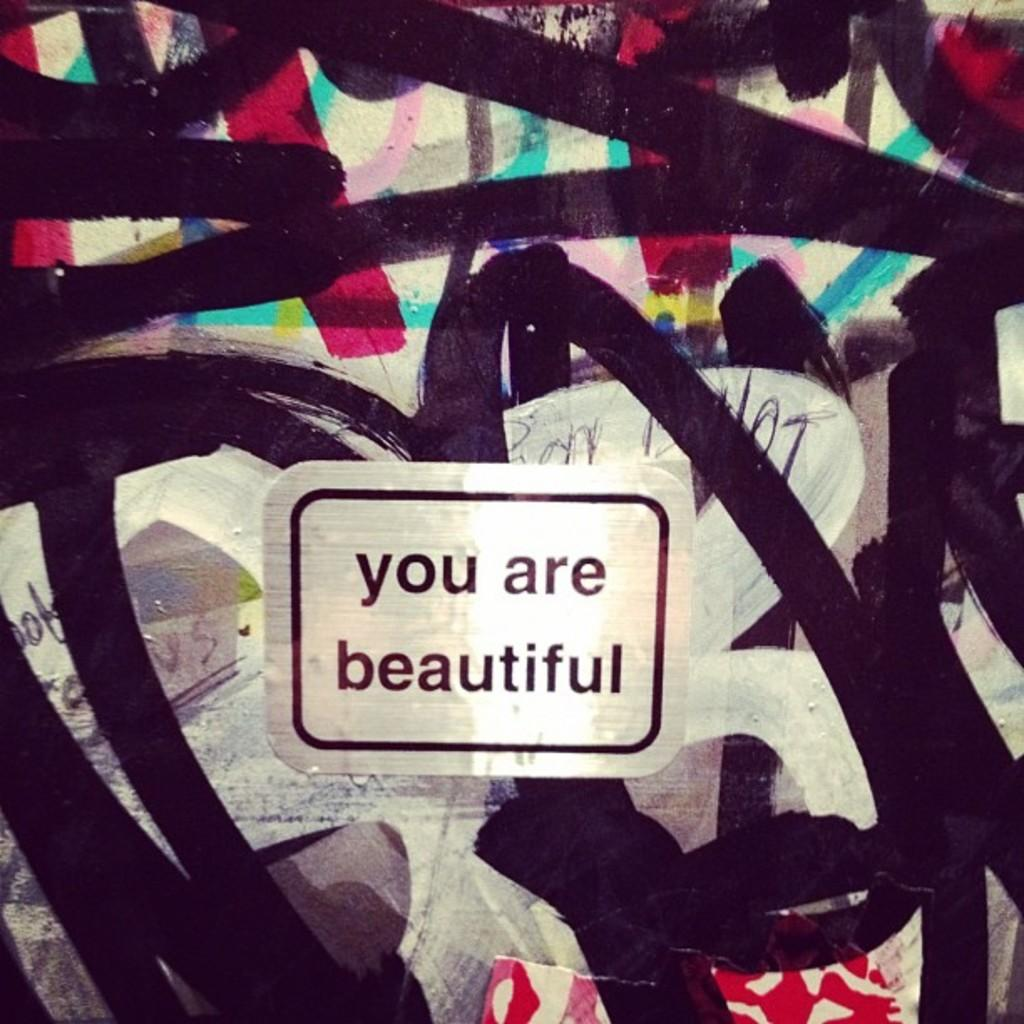What is the main subject of the image? There is a painting in the center of the image. What else can be seen in the image besides the painting? There is a label with text in the image. What does the text on the label say? The text on the label says "you are beautiful." What holiday is being celebrated in the image? There is no indication of a holiday being celebrated in the image. What color is the push button in the image? There is no push button present in the image. 